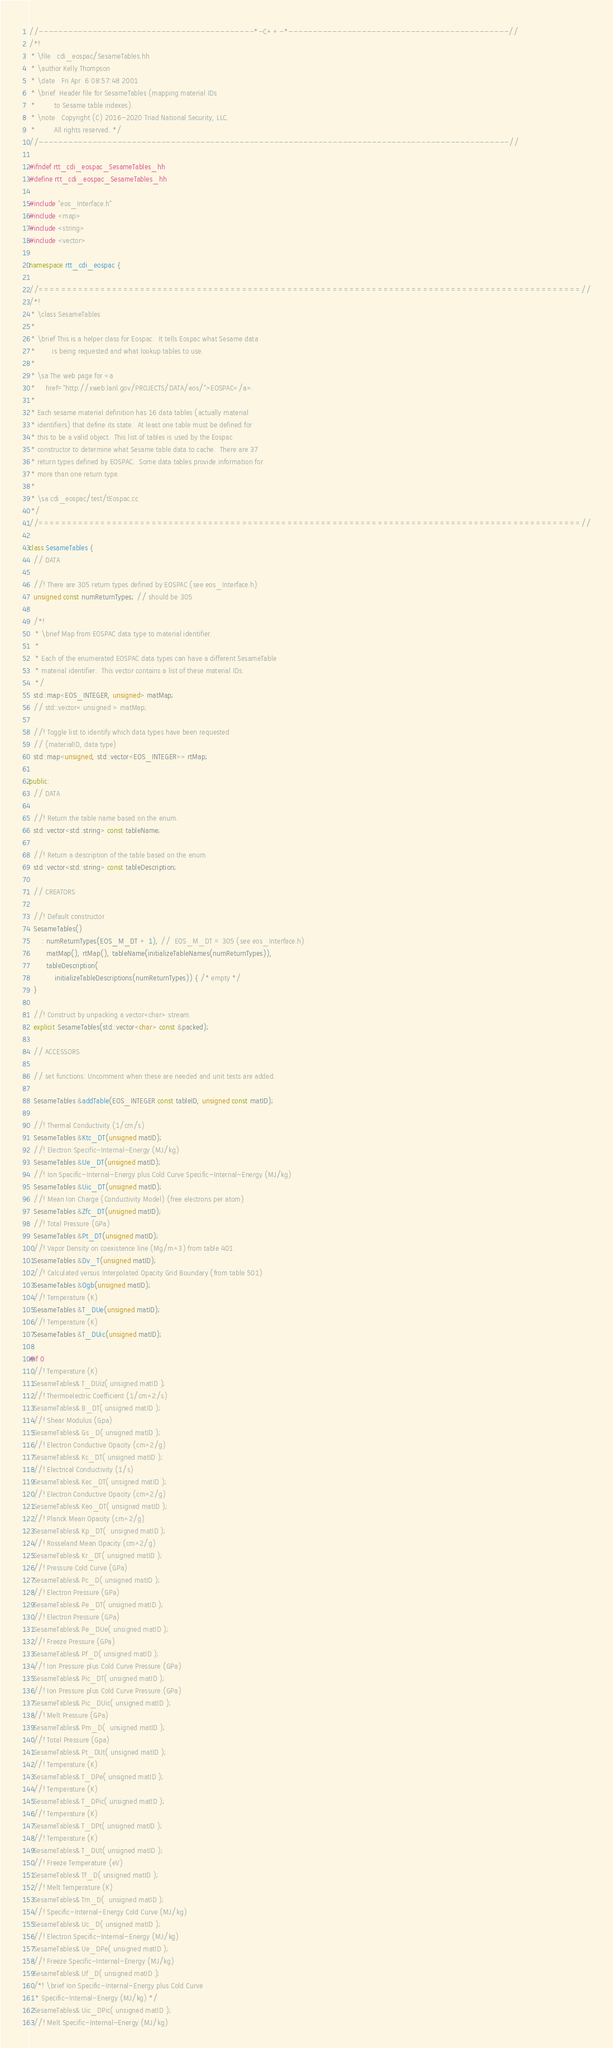<code> <loc_0><loc_0><loc_500><loc_500><_C++_>//--------------------------------------------*-C++-*---------------------------------------------//
/*!
 * \file   cdi_eospac/SesameTables.hh
 * \author Kelly Thompson
 * \date   Fri Apr  6 08:57:48 2001
 * \brief  Header file for SesameTables (mapping material IDs
 *         to Sesame table indexes).
 * \note   Copyright (C) 2016-2020 Triad National Security, LLC.
 *         All rights reserved. */
//------------------------------------------------------------------------------------------------//

#ifndef rtt_cdi_eospac_SesameTables_hh
#define rtt_cdi_eospac_SesameTables_hh

#include "eos_Interface.h"
#include <map>
#include <string>
#include <vector>

namespace rtt_cdi_eospac {

//================================================================================================//
/*!
 * \class SesameTables
 *
 * \brief This is a helper class for Eospac.  It tells Eospac what Sesame data
 *        is being requested and what lookup tables to use.
 *
 * \sa The web page for <a
 *     href="http://xweb.lanl.gov/PROJECTS/DATA/eos/">EOSPAC</a>.
 *
 * Each sesame material definition has 16 data tables (actually material
 * identifiers) that define its state.  At least one table must be defined for
 * this to be a valid object.  This list of tables is used by the Eospac
 * constructor to determine what Sesame table data to cache.  There are 37
 * return types defined by EOSPAC.  Some data tables provide information for
 * more than one return type.
 *
 * \sa cdi_eospac/test/tEospac.cc
 */
//================================================================================================//

class SesameTables {
  // DATA

  //! There are 305 return types defined by EOSPAC (see eos_Interface.h)
  unsigned const numReturnTypes; // should be 305

  /*!
   * \brief Map from EOSPAC data type to material identifier.
   *
   * Each of the enumerated EOSPAC data types can have a different SesameTable
   * material identifier.  This vector contains a list of these material IDs.
   */
  std::map<EOS_INTEGER, unsigned> matMap;
  // std::vector< unsigned > matMap;

  //! Toggle list to identify which data types have been requested
  // (materialID, data type)
  std::map<unsigned, std::vector<EOS_INTEGER>> rtMap;

public:
  // DATA

  //! Return the table name based on the enum.
  std::vector<std::string> const tableName;

  //! Return a description of the table based on the enum
  std::vector<std::string> const tableDescription;

  // CREATORS

  //! Default constructor
  SesameTables()
      : numReturnTypes(EOS_M_DT + 1), //  EOS_M_DT = 305 (see eos_Interface.h)
        matMap(), rtMap(), tableName(initializeTableNames(numReturnTypes)),
        tableDescription(
            initializeTableDescriptions(numReturnTypes)) { /* empty */
  }

  //! Construct by unpacking a vector<char> stream.
  explicit SesameTables(std::vector<char> const &packed);

  // ACCESSORS

  // set functions: Uncomment when these are needed and unit tests are added.

  SesameTables &addTable(EOS_INTEGER const tableID, unsigned const matID);

  //! Thermal Conductivity (1/cm/s)
  SesameTables &Ktc_DT(unsigned matID);
  //! Electron Specific-Internal-Energy (MJ/kg)
  SesameTables &Ue_DT(unsigned matID);
  //! Ion Specific-Internal-Energy plus Cold Curve Specific-Internal-Energy (MJ/kg)
  SesameTables &Uic_DT(unsigned matID);
  //! Mean Ion Charge (Conductivity Model) (free electrons per atom)
  SesameTables &Zfc_DT(unsigned matID);
  //! Total Pressure (GPa)
  SesameTables &Pt_DT(unsigned matID);
  //! Vapor Density on coexistence line (Mg/m^3) from table 401
  SesameTables &Dv_T(unsigned matID);
  //! Calculated versus Interpolated Opacity Grid Boundary (from table 501)
  SesameTables &Ogb(unsigned matID);
  //! Temperature (K)
  SesameTables &T_DUe(unsigned matID);
  //! Temperature (K)
  SesameTables &T_DUic(unsigned matID);

#if 0
  //! Temperature (K)
  SesameTables& T_DUiz( unsigned matID );
  //! Thermoelectric Coefficient (1/cm^2/s)
  SesameTables& B_DT( unsigned matID );
  //! Shear Modulus (Gpa)
  SesameTables& Gs_D( unsigned matID );
  //! Electron Conductive Opacity (cm^2/g)
  SesameTables& Kc_DT( unsigned matID );
  //! Electrical Conductivity (1/s)
  SesameTables& Kec_DT( unsigned matID );
  //! Electron Conductive Opacity (cm^2/g)
  SesameTables& Keo_DT( unsigned matID );
  //! Planck Mean Opacity (cm^2/g)
  SesameTables& Kp_DT(  unsigned matID );
  //! Rosseland Mean Opacity (cm^2/g)
  SesameTables& Kr_DT( unsigned matID );
  //! Pressure Cold Curve (GPa)
  SesameTables& Pc_D( unsigned matID );
  //! Electron Pressure (GPa)
  SesameTables& Pe_DT( unsigned matID );
  //! Electron Pressure (GPa)
  SesameTables& Pe_DUe( unsigned matID );
  //! Freeze Pressure (GPa)
  SesameTables& Pf_D( unsigned matID );
  //! Ion Pressure plus Cold Curve Pressure (GPa)
  SesameTables& Pic_DT( unsigned matID );
  //! Ion Pressure plus Cold Curve Pressure (GPa)
  SesameTables& Pic_DUic( unsigned matID );
  //! Melt Pressure (GPa)
  SesameTables& Pm_D(  unsigned matID );
  //! Total Pressure (Gpa)
  SesameTables& Pt_DUt( unsigned matID );
  //! Temperature (K)
  SesameTables& T_DPe( unsigned matID );
  //! Temperature (K)
  SesameTables& T_DPic( unsigned matID );
  //! Temperature (K)
  SesameTables& T_DPt( unsigned matID );
  //! Temperature (K)
  SesameTables& T_DUt( unsigned matID );
  //! Freeze Temperature (eV)
  SesameTables& Tf_D( unsigned matID );
  //! Melt Temperature (K)
  SesameTables& Tm_D(  unsigned matID );
  //! Specific-Internal-Energy Cold Curve (MJ/kg)
  SesameTables& Uc_D( unsigned matID );
  //! Electron Specific-Internal-Energy (MJ/kg)
  SesameTables& Ue_DPe( unsigned matID );
  //! Freeze Specific-Internal-Energy (MJ/kg)
  SesameTables& Uf_D( unsigned matID );
  /*! \brief Ion Specific-Internal-Energy plus Cold Curve
   * Specific-Internal-Energy (MJ/kg) */
  SesameTables& Uic_DPic( unsigned matID );
  //! Melt Specific-Internal-Energy (MJ/kg)</code> 